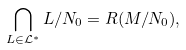<formula> <loc_0><loc_0><loc_500><loc_500>\bigcap _ { L \in \mathcal { L } ^ { * } } L / N _ { 0 } = R ( M / N _ { 0 } ) ,</formula> 